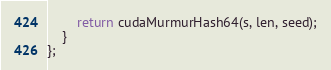Convert code to text. <code><loc_0><loc_0><loc_500><loc_500><_Cuda_>        return cudaMurmurHash64(s, len, seed);
    }
};</code> 